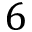Convert formula to latex. <formula><loc_0><loc_0><loc_500><loc_500>6</formula> 